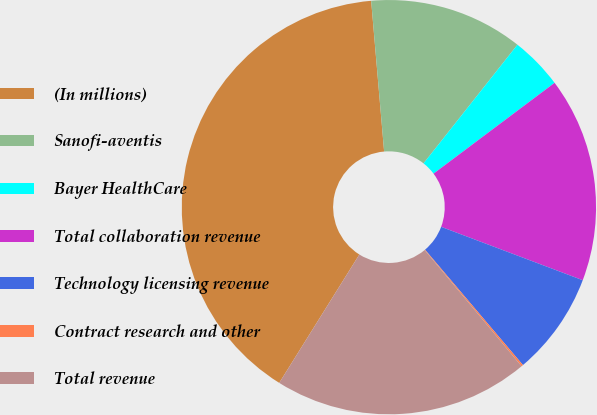Convert chart to OTSL. <chart><loc_0><loc_0><loc_500><loc_500><pie_chart><fcel>(In millions)<fcel>Sanofi-aventis<fcel>Bayer HealthCare<fcel>Total collaboration revenue<fcel>Technology licensing revenue<fcel>Contract research and other<fcel>Total revenue<nl><fcel>39.75%<fcel>12.02%<fcel>4.1%<fcel>15.98%<fcel>8.06%<fcel>0.14%<fcel>19.94%<nl></chart> 